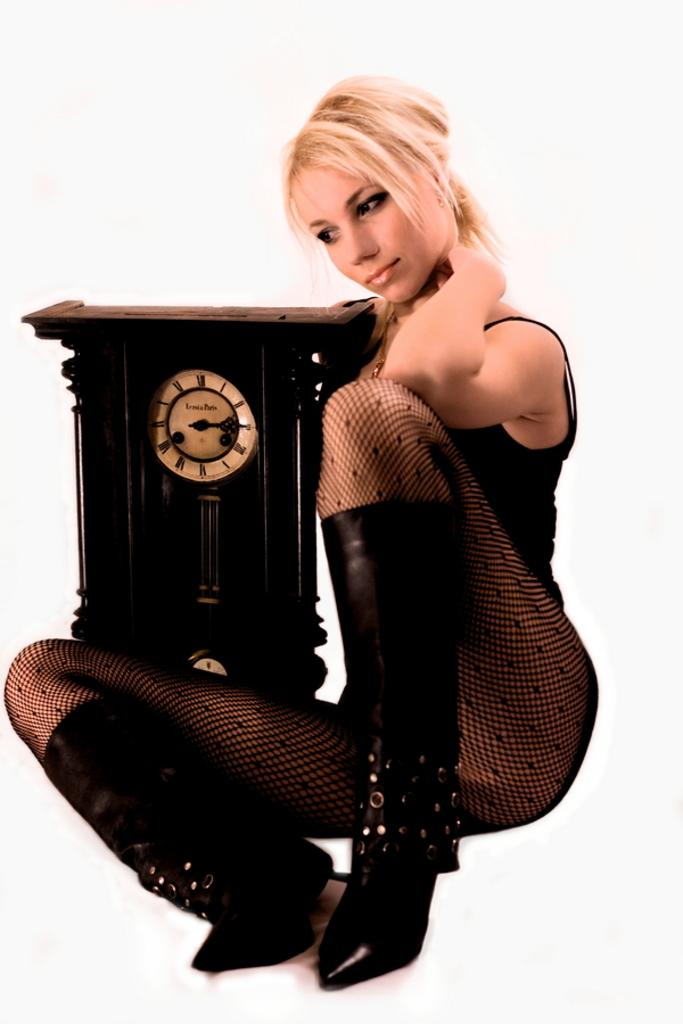Who is present in the image? There is a woman in the picture. What is the woman sitting beside? The woman is sitting beside a wooden clock. Which direction is the woman looking? The woman is looking to the left side. What is the color of the background in the image? There is a white background in the image. What type of cheese is the woman holding in the image? There is no cheese present in the image; the woman is sitting beside a wooden clock. How many goldfish are swimming in the background of the image? There are no goldfish present in the image; the background is white. 